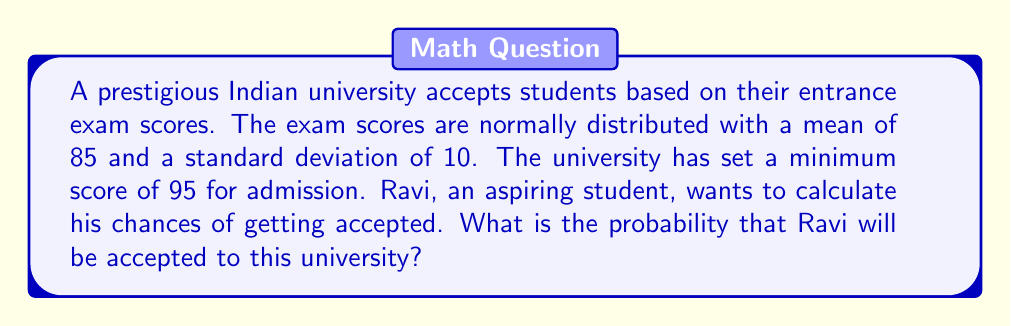Teach me how to tackle this problem. Let's approach this step-by-step:

1) We are dealing with a normal distribution where:
   $\mu = 85$ (mean)
   $\sigma = 10$ (standard deviation)
   The cutoff score is 95.

2) To find the probability, we need to calculate the z-score for the cutoff value:

   $$z = \frac{x - \mu}{\sigma} = \frac{95 - 85}{10} = 1$$

3) This z-score of 1 represents the number of standard deviations above the mean.

4) We need to find the probability of scoring above this z-score. In a standard normal distribution, this is represented by the area to the right of z = 1.

5) Using a standard normal distribution table or calculator, we can find that:
   $P(Z > 1) = 1 - P(Z < 1) = 1 - 0.8413 = 0.1587$

6) Therefore, the probability of scoring 95 or above is approximately 0.1587 or 15.87%.

[asy]
import graph;
size(200,150);
real f(real x) {return exp(-x^2/2)/sqrt(2pi);}
draw(graph(f,-3,3),blue);
fill(graph(f,1,3)--cycle,gray(0.7));
label("$\mu$",(0,-0.05),S);
label("95",(1,-0.05),S);
draw((1,0)--(1,f(1)),dashed);
label("15.87%",(2,0.1));
[/asy]
Answer: 0.1587 or 15.87% 